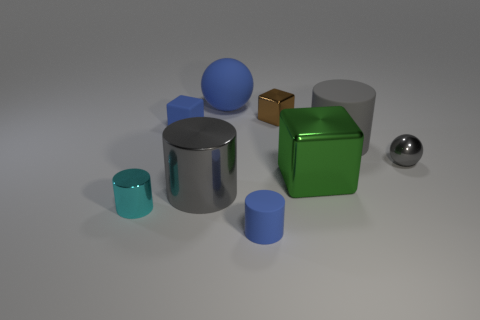What is the size of the metallic object that is left of the rubber ball and on the right side of the tiny metal cylinder?
Give a very brief answer. Large. What is the shape of the green thing?
Give a very brief answer. Cube. There is a metal thing behind the tiny gray sphere; is there a large gray metallic object that is right of it?
Provide a succinct answer. No. How many tiny metallic objects are right of the large metal object that is to the left of the tiny brown shiny cube?
Offer a terse response. 2. What material is the cyan cylinder that is the same size as the gray shiny sphere?
Offer a very short reply. Metal. There is a blue rubber object that is in front of the blue rubber cube; is it the same shape as the small cyan object?
Offer a very short reply. Yes. Is the number of tiny shiny things behind the small brown thing greater than the number of tiny cyan metallic cylinders that are to the right of the tiny matte block?
Provide a succinct answer. No. How many small cylinders are made of the same material as the blue ball?
Give a very brief answer. 1. Is the gray metallic sphere the same size as the brown metal thing?
Provide a short and direct response. Yes. The small metal block is what color?
Ensure brevity in your answer.  Brown. 